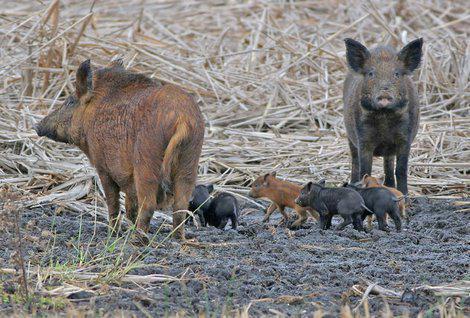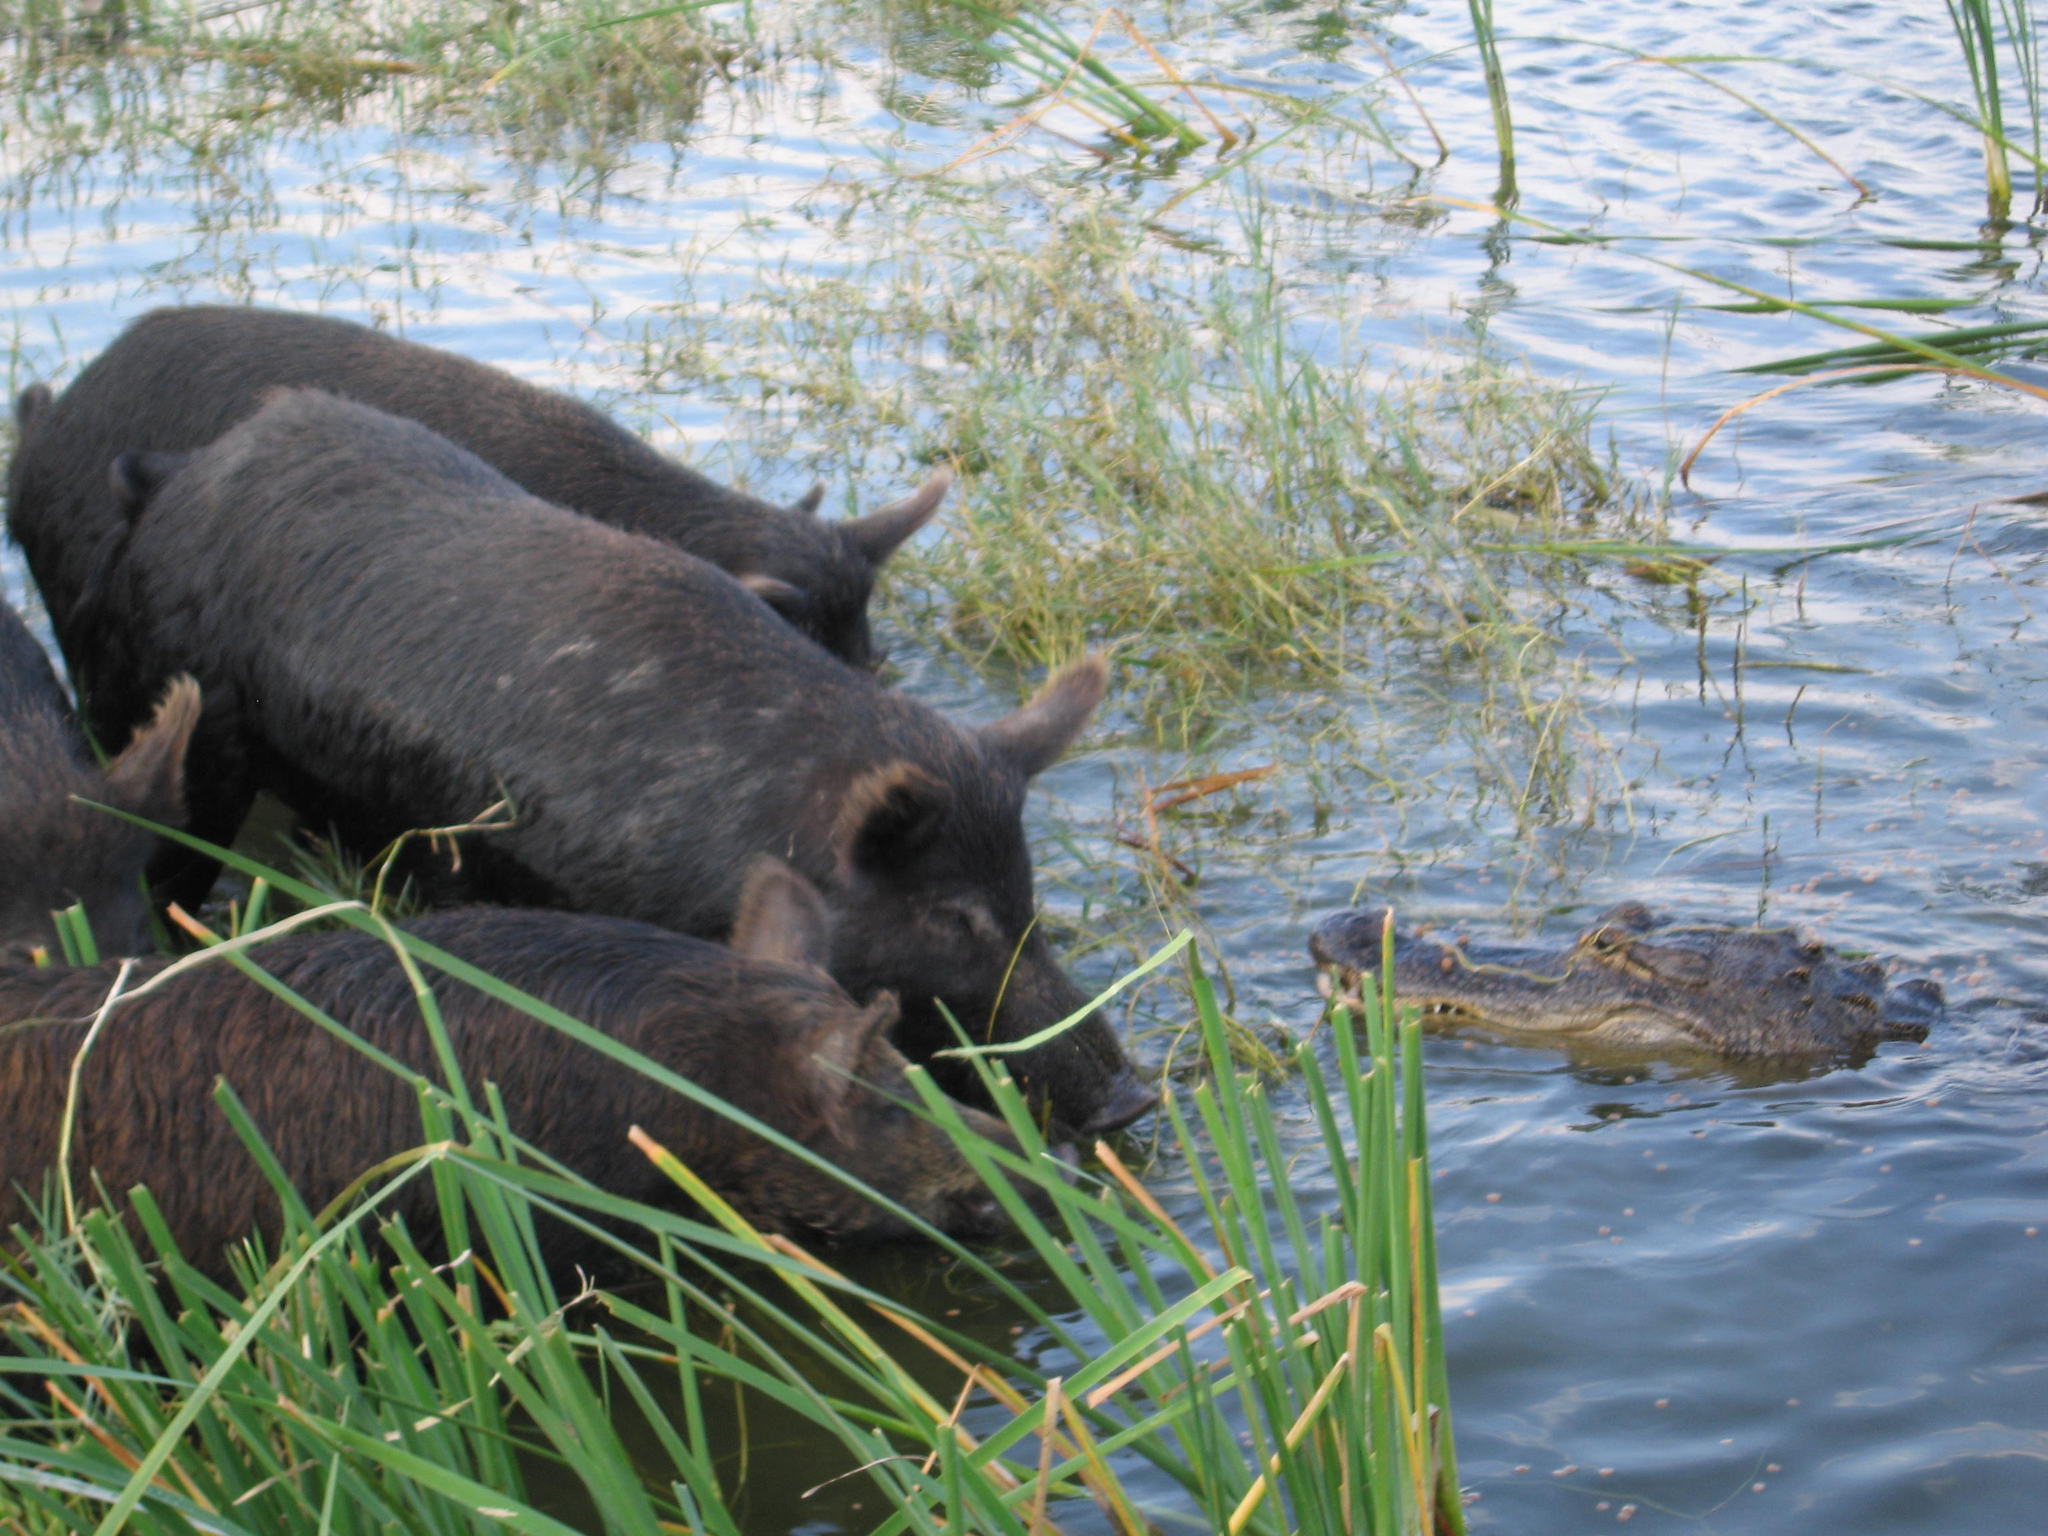The first image is the image on the left, the second image is the image on the right. Given the left and right images, does the statement "Left image shows at least 8 dark hogs in a cleared area next to foliage." hold true? Answer yes or no. No. The first image is the image on the left, the second image is the image on the right. Given the left and right images, does the statement "One or more boars are facing a predator in the right image." hold true? Answer yes or no. Yes. 